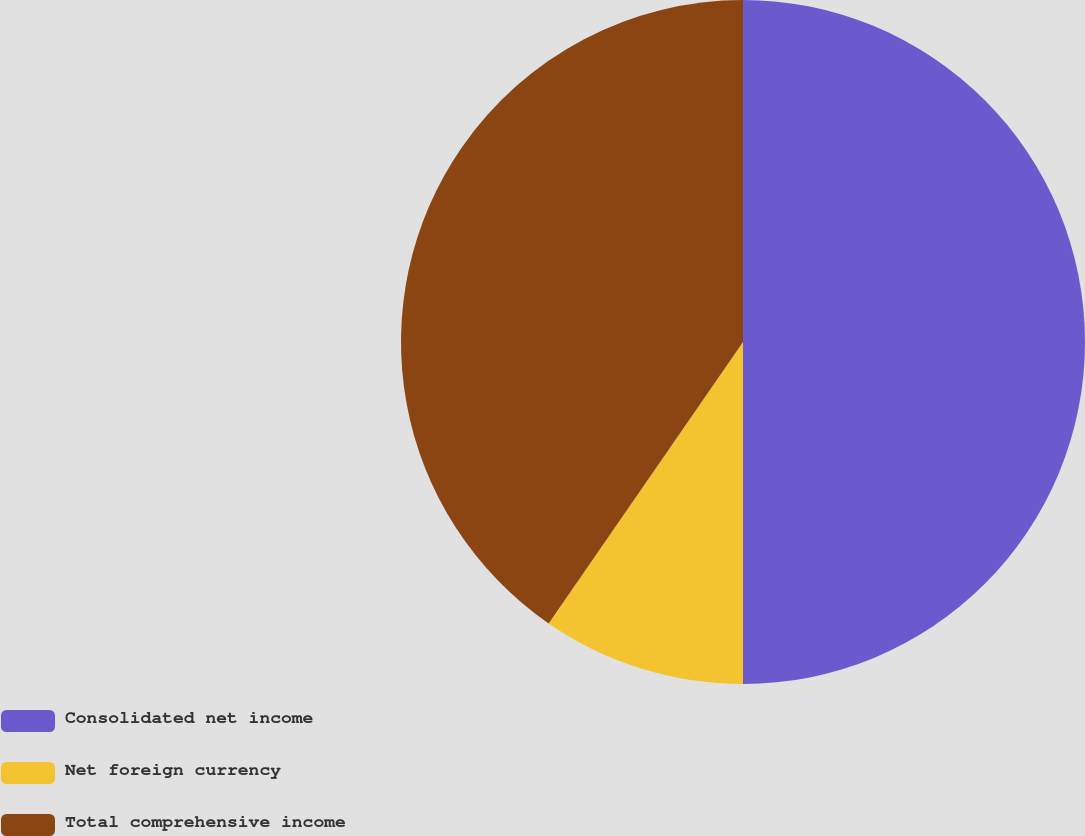Convert chart to OTSL. <chart><loc_0><loc_0><loc_500><loc_500><pie_chart><fcel>Consolidated net income<fcel>Net foreign currency<fcel>Total comprehensive income<nl><fcel>50.0%<fcel>9.62%<fcel>40.38%<nl></chart> 